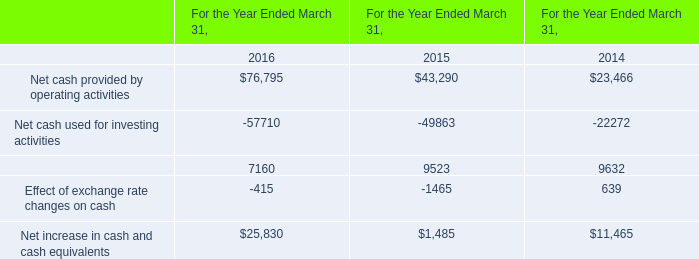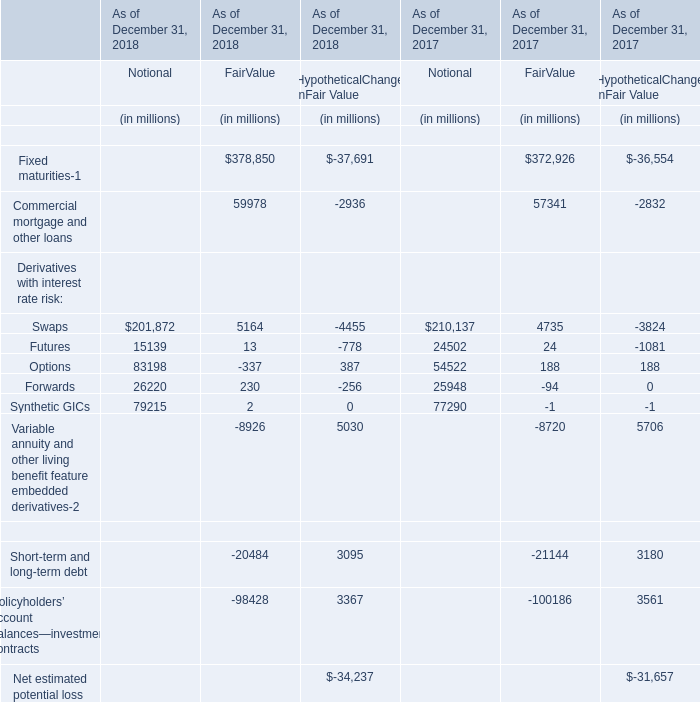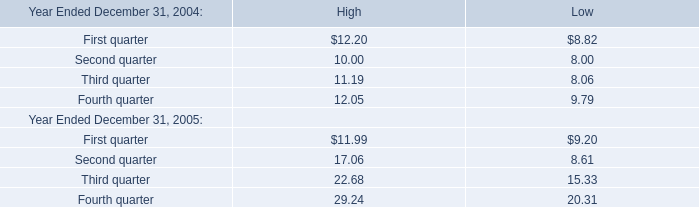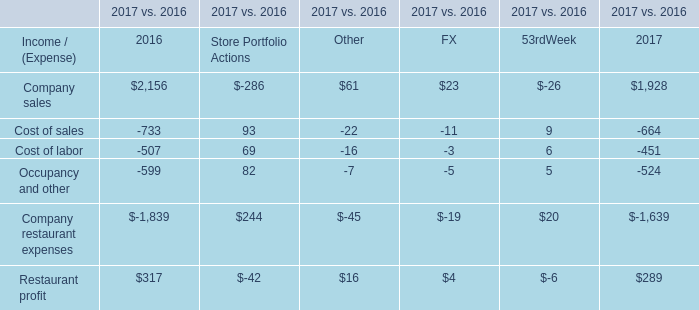What's the sum of all Notional that are greater than 80000 in 2018? (in million) 
Computations: (201872 + 83198)
Answer: 285070.0. 